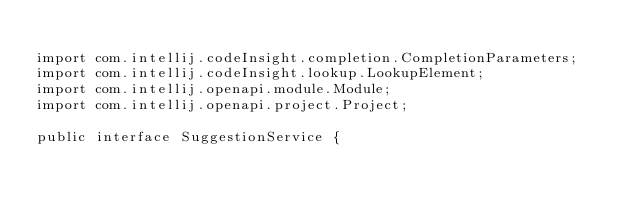<code> <loc_0><loc_0><loc_500><loc_500><_Java_>
import com.intellij.codeInsight.completion.CompletionParameters;
import com.intellij.codeInsight.lookup.LookupElement;
import com.intellij.openapi.module.Module;
import com.intellij.openapi.project.Project;

public interface SuggestionService {
</code> 